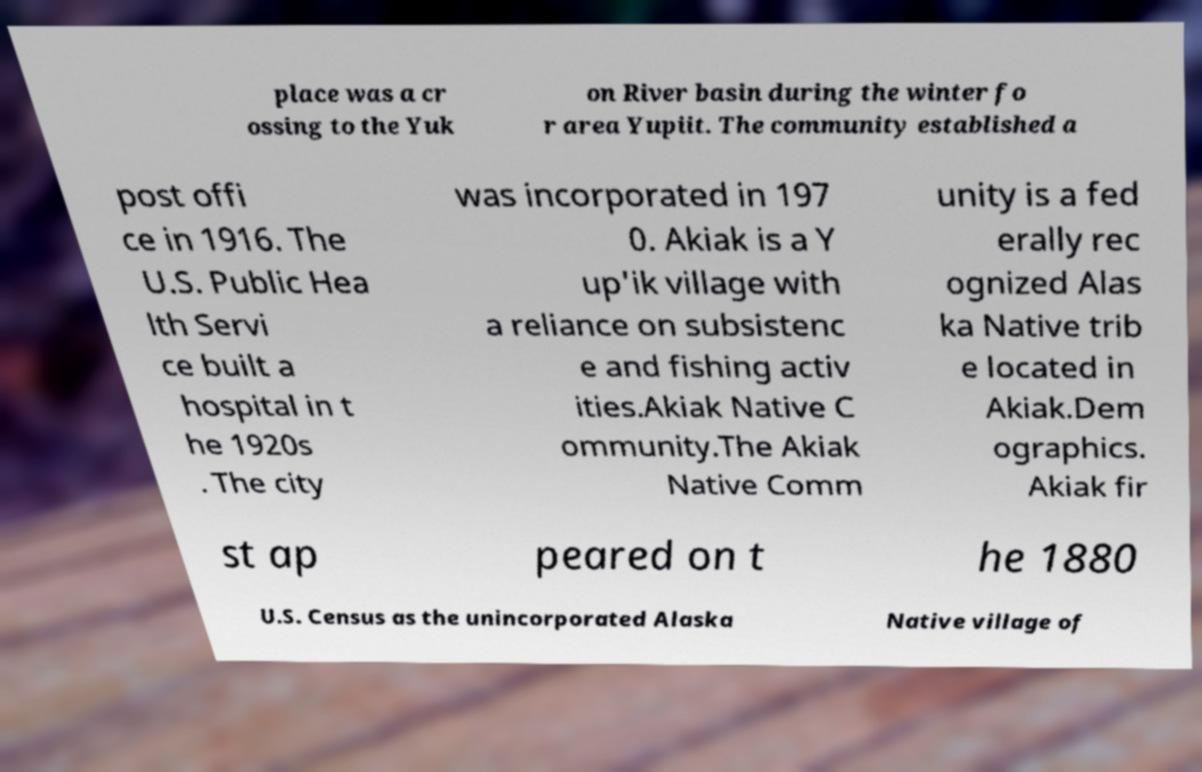Can you accurately transcribe the text from the provided image for me? place was a cr ossing to the Yuk on River basin during the winter fo r area Yupiit. The community established a post offi ce in 1916. The U.S. Public Hea lth Servi ce built a hospital in t he 1920s . The city was incorporated in 197 0. Akiak is a Y up'ik village with a reliance on subsistenc e and fishing activ ities.Akiak Native C ommunity.The Akiak Native Comm unity is a fed erally rec ognized Alas ka Native trib e located in Akiak.Dem ographics. Akiak fir st ap peared on t he 1880 U.S. Census as the unincorporated Alaska Native village of 